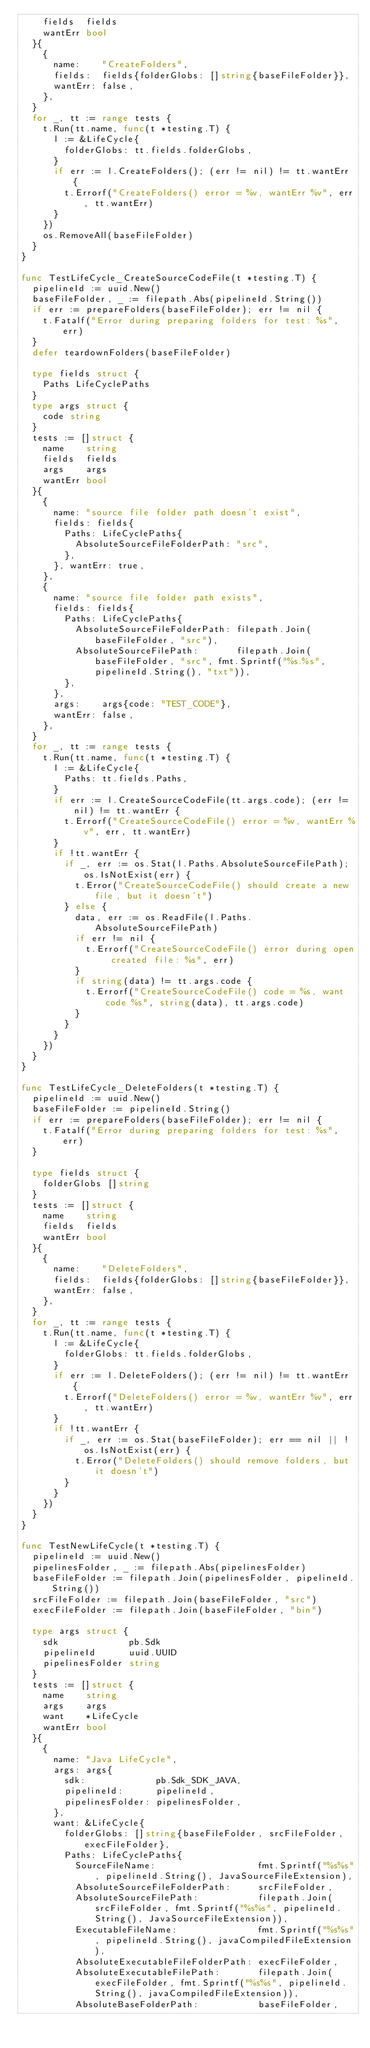Convert code to text. <code><loc_0><loc_0><loc_500><loc_500><_Go_>		fields  fields
		wantErr bool
	}{
		{
			name:    "CreateFolders",
			fields:  fields{folderGlobs: []string{baseFileFolder}},
			wantErr: false,
		},
	}
	for _, tt := range tests {
		t.Run(tt.name, func(t *testing.T) {
			l := &LifeCycle{
				folderGlobs: tt.fields.folderGlobs,
			}
			if err := l.CreateFolders(); (err != nil) != tt.wantErr {
				t.Errorf("CreateFolders() error = %v, wantErr %v", err, tt.wantErr)
			}
		})
		os.RemoveAll(baseFileFolder)
	}
}

func TestLifeCycle_CreateSourceCodeFile(t *testing.T) {
	pipelineId := uuid.New()
	baseFileFolder, _ := filepath.Abs(pipelineId.String())
	if err := prepareFolders(baseFileFolder); err != nil {
		t.Fatalf("Error during preparing folders for test: %s", err)
	}
	defer teardownFolders(baseFileFolder)

	type fields struct {
		Paths LifeCyclePaths
	}
	type args struct {
		code string
	}
	tests := []struct {
		name    string
		fields  fields
		args    args
		wantErr bool
	}{
		{
			name: "source file folder path doesn't exist",
			fields: fields{
				Paths: LifeCyclePaths{
					AbsoluteSourceFileFolderPath: "src",
				},
			}, wantErr: true,
		},
		{
			name: "source file folder path exists",
			fields: fields{
				Paths: LifeCyclePaths{
					AbsoluteSourceFileFolderPath: filepath.Join(baseFileFolder, "src"),
					AbsoluteSourceFilePath:       filepath.Join(baseFileFolder, "src", fmt.Sprintf("%s.%s", pipelineId.String(), "txt")),
				},
			},
			args:    args{code: "TEST_CODE"},
			wantErr: false,
		},
	}
	for _, tt := range tests {
		t.Run(tt.name, func(t *testing.T) {
			l := &LifeCycle{
				Paths: tt.fields.Paths,
			}
			if err := l.CreateSourceCodeFile(tt.args.code); (err != nil) != tt.wantErr {
				t.Errorf("CreateSourceCodeFile() error = %v, wantErr %v", err, tt.wantErr)
			}
			if !tt.wantErr {
				if _, err := os.Stat(l.Paths.AbsoluteSourceFilePath); os.IsNotExist(err) {
					t.Error("CreateSourceCodeFile() should create a new file, but it doesn't")
				} else {
					data, err := os.ReadFile(l.Paths.AbsoluteSourceFilePath)
					if err != nil {
						t.Errorf("CreateSourceCodeFile() error during open created file: %s", err)
					}
					if string(data) != tt.args.code {
						t.Errorf("CreateSourceCodeFile() code = %s, want code %s", string(data), tt.args.code)
					}
				}
			}
		})
	}
}

func TestLifeCycle_DeleteFolders(t *testing.T) {
	pipelineId := uuid.New()
	baseFileFolder := pipelineId.String()
	if err := prepareFolders(baseFileFolder); err != nil {
		t.Fatalf("Error during preparing folders for test: %s", err)
	}

	type fields struct {
		folderGlobs []string
	}
	tests := []struct {
		name    string
		fields  fields
		wantErr bool
	}{
		{
			name:    "DeleteFolders",
			fields:  fields{folderGlobs: []string{baseFileFolder}},
			wantErr: false,
		},
	}
	for _, tt := range tests {
		t.Run(tt.name, func(t *testing.T) {
			l := &LifeCycle{
				folderGlobs: tt.fields.folderGlobs,
			}
			if err := l.DeleteFolders(); (err != nil) != tt.wantErr {
				t.Errorf("DeleteFolders() error = %v, wantErr %v", err, tt.wantErr)
			}
			if !tt.wantErr {
				if _, err := os.Stat(baseFileFolder); err == nil || !os.IsNotExist(err) {
					t.Error("DeleteFolders() should remove folders, but it doesn't")
				}
			}
		})
	}
}

func TestNewLifeCycle(t *testing.T) {
	pipelineId := uuid.New()
	pipelinesFolder, _ := filepath.Abs(pipelinesFolder)
	baseFileFolder := filepath.Join(pipelinesFolder, pipelineId.String())
	srcFileFolder := filepath.Join(baseFileFolder, "src")
	execFileFolder := filepath.Join(baseFileFolder, "bin")

	type args struct {
		sdk             pb.Sdk
		pipelineId      uuid.UUID
		pipelinesFolder string
	}
	tests := []struct {
		name    string
		args    args
		want    *LifeCycle
		wantErr bool
	}{
		{
			name: "Java LifeCycle",
			args: args{
				sdk:             pb.Sdk_SDK_JAVA,
				pipelineId:      pipelineId,
				pipelinesFolder: pipelinesFolder,
			},
			want: &LifeCycle{
				folderGlobs: []string{baseFileFolder, srcFileFolder, execFileFolder},
				Paths: LifeCyclePaths{
					SourceFileName:                   fmt.Sprintf("%s%s", pipelineId.String(), JavaSourceFileExtension),
					AbsoluteSourceFileFolderPath:     srcFileFolder,
					AbsoluteSourceFilePath:           filepath.Join(srcFileFolder, fmt.Sprintf("%s%s", pipelineId.String(), JavaSourceFileExtension)),
					ExecutableFileName:               fmt.Sprintf("%s%s", pipelineId.String(), javaCompiledFileExtension),
					AbsoluteExecutableFileFolderPath: execFileFolder,
					AbsoluteExecutableFilePath:       filepath.Join(execFileFolder, fmt.Sprintf("%s%s", pipelineId.String(), javaCompiledFileExtension)),
					AbsoluteBaseFolderPath:           baseFileFolder,</code> 